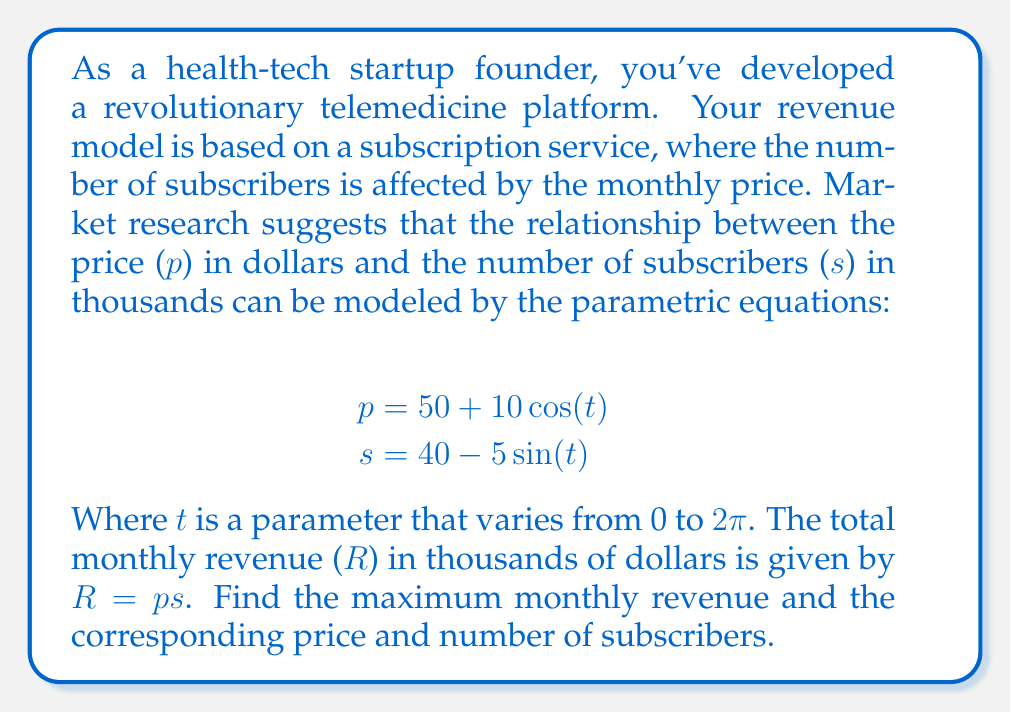Help me with this question. To solve this problem, we'll follow these steps:

1) First, we need to express the revenue R in terms of the parameter t:
   $$R = ps = (50 + 10\cos(t))(40 - 5\sin(t))$$

2) Expand this expression:
   $$R = 2000 - 250\sin(t) + 400\cos(t) - 50\cos(t)\sin(t)$$

3) To find the maximum revenue, we need to find where $\frac{dR}{dt} = 0$:
   $$\frac{dR}{dt} = -250\cos(t) - 400\sin(t) - 50(\cos^2(t) - \sin^2(t))$$

4) Set this equal to zero and solve for t:
   $$-250\cos(t) - 400\sin(t) - 50(\cos^2(t) - \sin^2(t)) = 0$$

5) This equation is complex and doesn't have a simple analytical solution. We can solve it numerically or graphically to find that the maximum occurs at approximately $t \approx 5.92$ radians.

6) Plug this value of t back into the original equations to find p and s:
   $$p \approx 50 + 10\cos(5.92) \approx 45.08$$
   $$s \approx 40 - 5\sin(5.92) \approx 35.16$$

7) Calculate the maximum revenue:
   $$R_{max} \approx 45.08 * 35.16 \approx 1584.81$$

Therefore, the maximum monthly revenue is approximately $1,584,810, achieved when the price is about $45.08 and the number of subscribers is about 35,160.
Answer: The maximum monthly revenue is approximately $1,584,810, achieved at a price of $45.08 and 35,160 subscribers. 